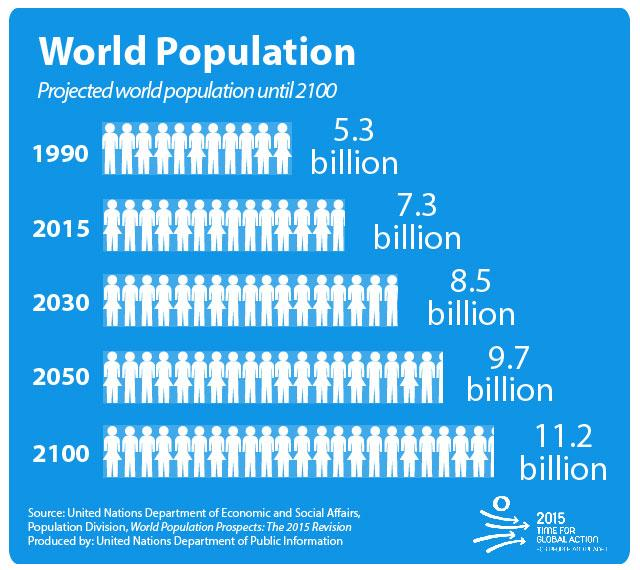Indicate a few pertinent items in this graphic. By 2100, the population is expected to reach 1.5 billion, an increase of approximately 50% from the projected population in 2050. The population in 2015 was two billion more than in 1990. The population in 2050 is expected to be 1.2 billion higher than in 2030. The population in 2030 is projected to be approximately 1.2 billion larger than it was in 2015. 